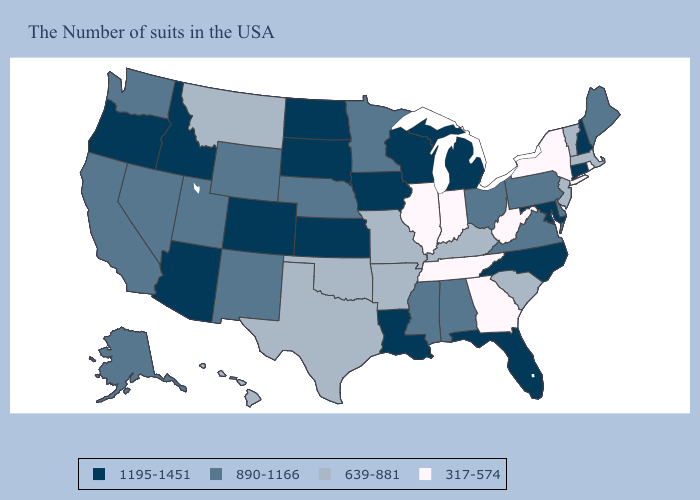What is the lowest value in the South?
Short answer required. 317-574. Does West Virginia have a higher value than Wisconsin?
Concise answer only. No. Name the states that have a value in the range 890-1166?
Answer briefly. Maine, Delaware, Pennsylvania, Virginia, Ohio, Alabama, Mississippi, Minnesota, Nebraska, Wyoming, New Mexico, Utah, Nevada, California, Washington, Alaska. Does Wisconsin have the same value as Utah?
Be succinct. No. What is the lowest value in states that border South Dakota?
Be succinct. 639-881. How many symbols are there in the legend?
Be succinct. 4. Does Florida have the highest value in the USA?
Keep it brief. Yes. Among the states that border Colorado , which have the lowest value?
Keep it brief. Oklahoma. Does Arizona have a higher value than Wisconsin?
Short answer required. No. How many symbols are there in the legend?
Keep it brief. 4. Name the states that have a value in the range 639-881?
Write a very short answer. Massachusetts, Vermont, New Jersey, South Carolina, Kentucky, Missouri, Arkansas, Oklahoma, Texas, Montana, Hawaii. Name the states that have a value in the range 1195-1451?
Be succinct. New Hampshire, Connecticut, Maryland, North Carolina, Florida, Michigan, Wisconsin, Louisiana, Iowa, Kansas, South Dakota, North Dakota, Colorado, Arizona, Idaho, Oregon. Which states have the highest value in the USA?
Answer briefly. New Hampshire, Connecticut, Maryland, North Carolina, Florida, Michigan, Wisconsin, Louisiana, Iowa, Kansas, South Dakota, North Dakota, Colorado, Arizona, Idaho, Oregon. What is the value of Minnesota?
Short answer required. 890-1166. What is the value of New Mexico?
Give a very brief answer. 890-1166. 